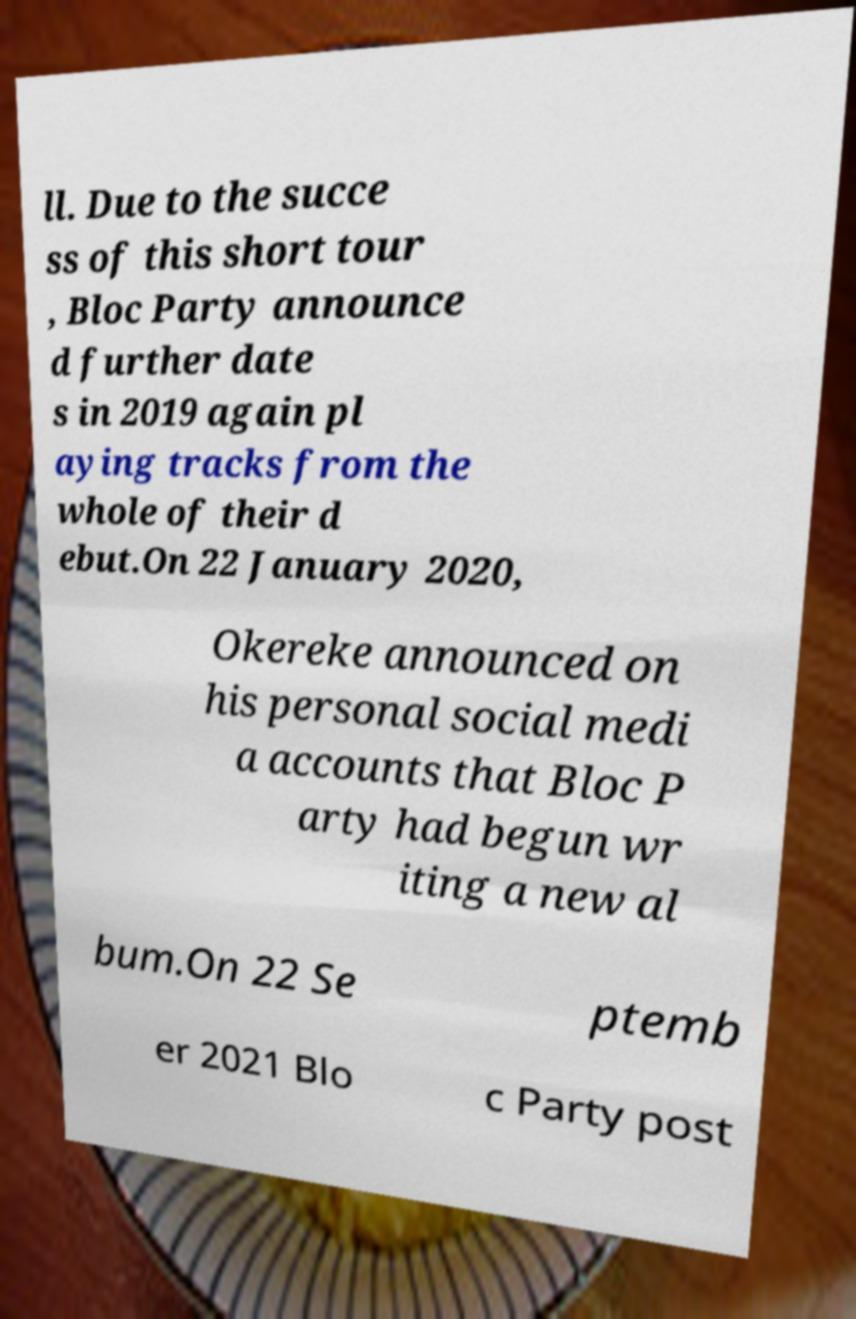Could you assist in decoding the text presented in this image and type it out clearly? ll. Due to the succe ss of this short tour , Bloc Party announce d further date s in 2019 again pl aying tracks from the whole of their d ebut.On 22 January 2020, Okereke announced on his personal social medi a accounts that Bloc P arty had begun wr iting a new al bum.On 22 Se ptemb er 2021 Blo c Party post 